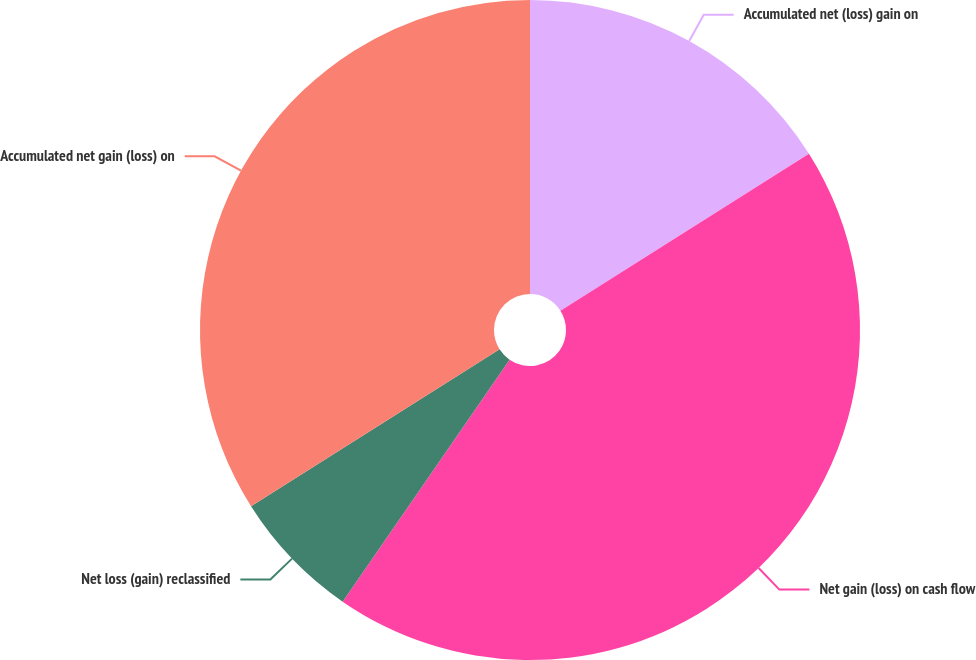Convert chart. <chart><loc_0><loc_0><loc_500><loc_500><pie_chart><fcel>Accumulated net (loss) gain on<fcel>Net gain (loss) on cash flow<fcel>Net loss (gain) reclassified<fcel>Accumulated net gain (loss) on<nl><fcel>16.03%<fcel>43.58%<fcel>6.42%<fcel>33.97%<nl></chart> 